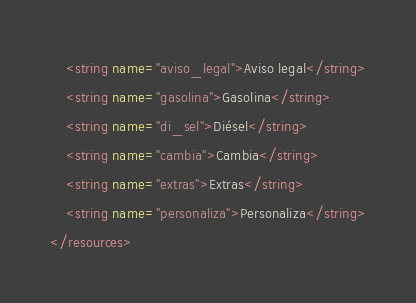Convert code to text. <code><loc_0><loc_0><loc_500><loc_500><_XML_>    <string name="aviso_legal">Aviso legal</string>
    <string name="gasolina">Gasolina</string>
    <string name="di_sel">Diésel</string>
    <string name="cambia">Cambia</string>
    <string name="extras">Extras</string>
    <string name="personaliza">Personaliza</string>
</resources>
</code> 